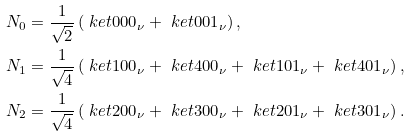Convert formula to latex. <formula><loc_0><loc_0><loc_500><loc_500>& N _ { 0 } = \frac { 1 } { \sqrt { 2 } } \left ( \ k e t { 0 0 0 } _ { \nu } + \ k e t { 0 0 1 } _ { \nu } \right ) , \\ & N _ { 1 } = \frac { 1 } { \sqrt { 4 } } \left ( \ k e t { 1 0 0 } _ { \nu } + \ k e t { 4 0 0 } _ { \nu } + \ k e t { 1 0 1 } _ { \nu } + \ k e t { 4 0 1 } _ { \nu } \right ) , \\ & N _ { 2 } = \frac { 1 } { \sqrt { 4 } } \left ( \ k e t { 2 0 0 } _ { \nu } + \ k e t { 3 0 0 } _ { \nu } + \ k e t { 2 0 1 } _ { \nu } + \ k e t { 3 0 1 } _ { \nu } \right ) .</formula> 